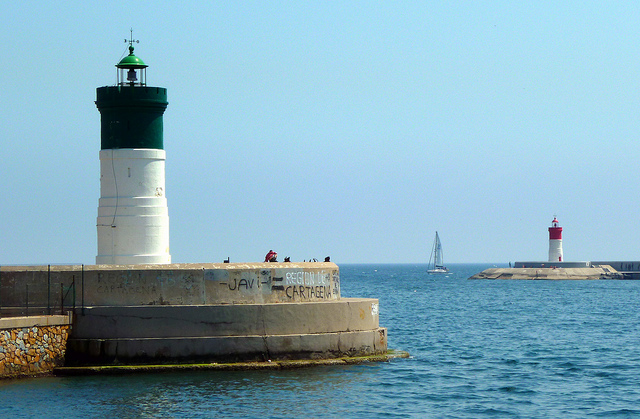Is there any maritime activity visible? Yes, there is a sailboat gliding on the water, likely enjoying the calm sea conditions. It adds a sense of serenity and activity to the scene. 